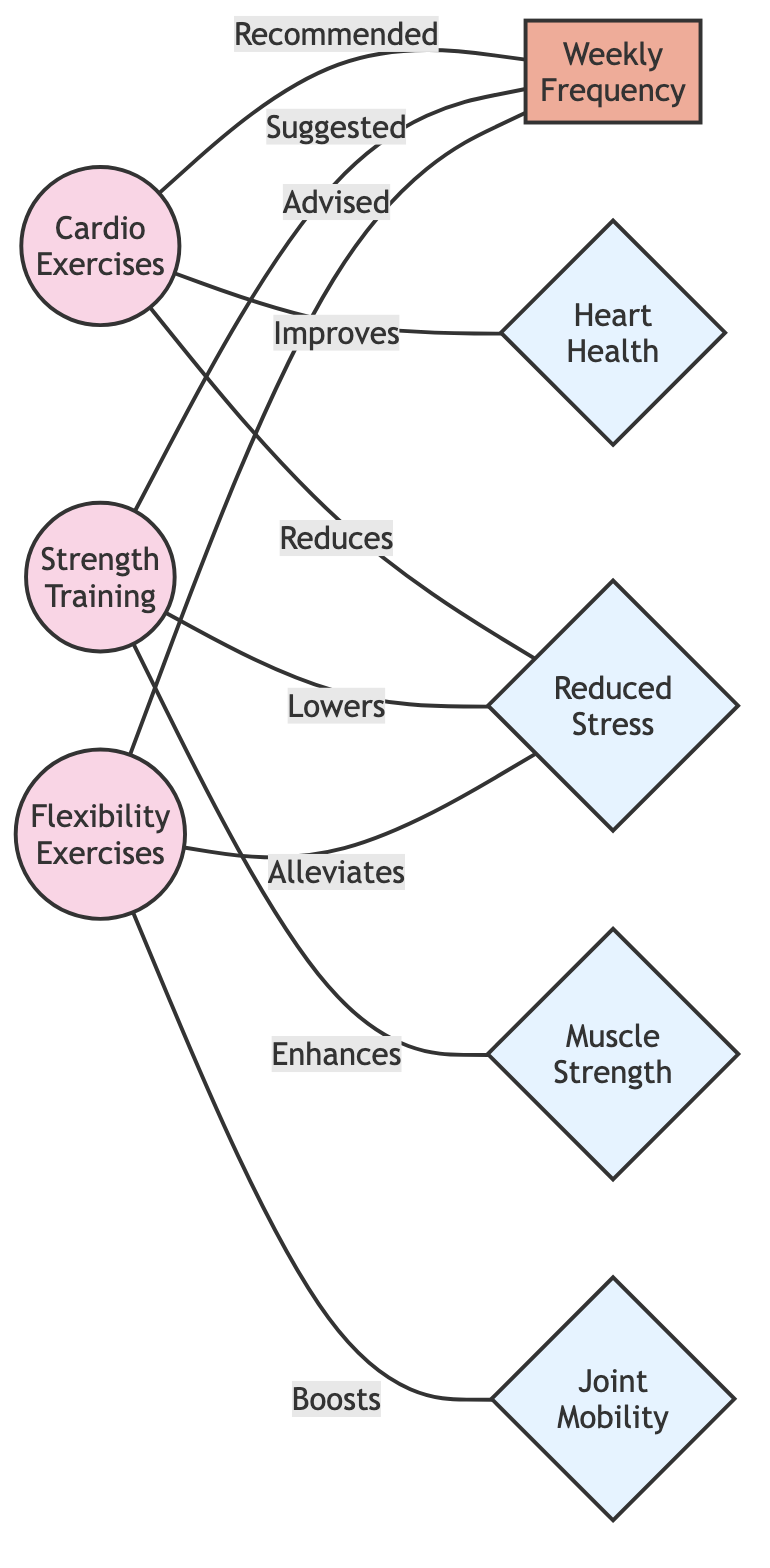What are the three types of exercises shown in the diagram? The diagram lists three distinct types of exercises: Cardio Exercises, Strength Training, and Flexibility Exercises. Each type is represented as a node in the diagram.
Answer: Cardio Exercises, Strength Training, Flexibility Exercises How many outcomes are connected to the exercises? There are four outcomes indicated in the diagram: Heart Health, Muscle Strength, Joint Mobility, and Reduced Stress. Each outcome is connected to the exercises through the edges illustrating their benefits.
Answer: Four Which exercise improves heart health? The diagram clearly indicates that Cardio Exercises have a direct edge labeled "Improves" that connects it to the Heart Health node. Thus, the only exercise that improves heart health is Cardio Exercises.
Answer: Cardio Exercises What is the recommended frequency of exercise mentioned for all types? The diagram specifies a node for Weekly Frequency and shows connections from all three types of exercises to this node, indicating that engaging in these exercises weekly is recommended.
Answer: Weekly Which exercise enhances muscle strength? From the diagram, Strength Training has an edge labeled "Enhances" that connects it to the Muscle Strength node, indicating that strength training enhances muscle strength.
Answer: Strength Training How is flexibility exercise associated with reduced stress? The diagram shows that Flexibility Exercises have an edge labeled "Alleviates" leading to the Reduced Stress node, establishing the connection that flexibility exercises have a positive association with stress reduction.
Answer: Alleviates What is the connection between strength training and reduced stress? Strength Training connects to Reduced Stress through an edge labeled "Lowers," indicating that strength training lowers stress levels, which is a direct benefit of engaging in that type of exercise.
Answer: Lowers Which exercise is most associated with joint mobility? The diagram explicitly states that Flexibility Exercises are linked to the Joint Mobility outcome with an edge labeled "Boosts," which indicates that flexibility exercises are most associated with joint mobility.
Answer: Flexibility Exercises 